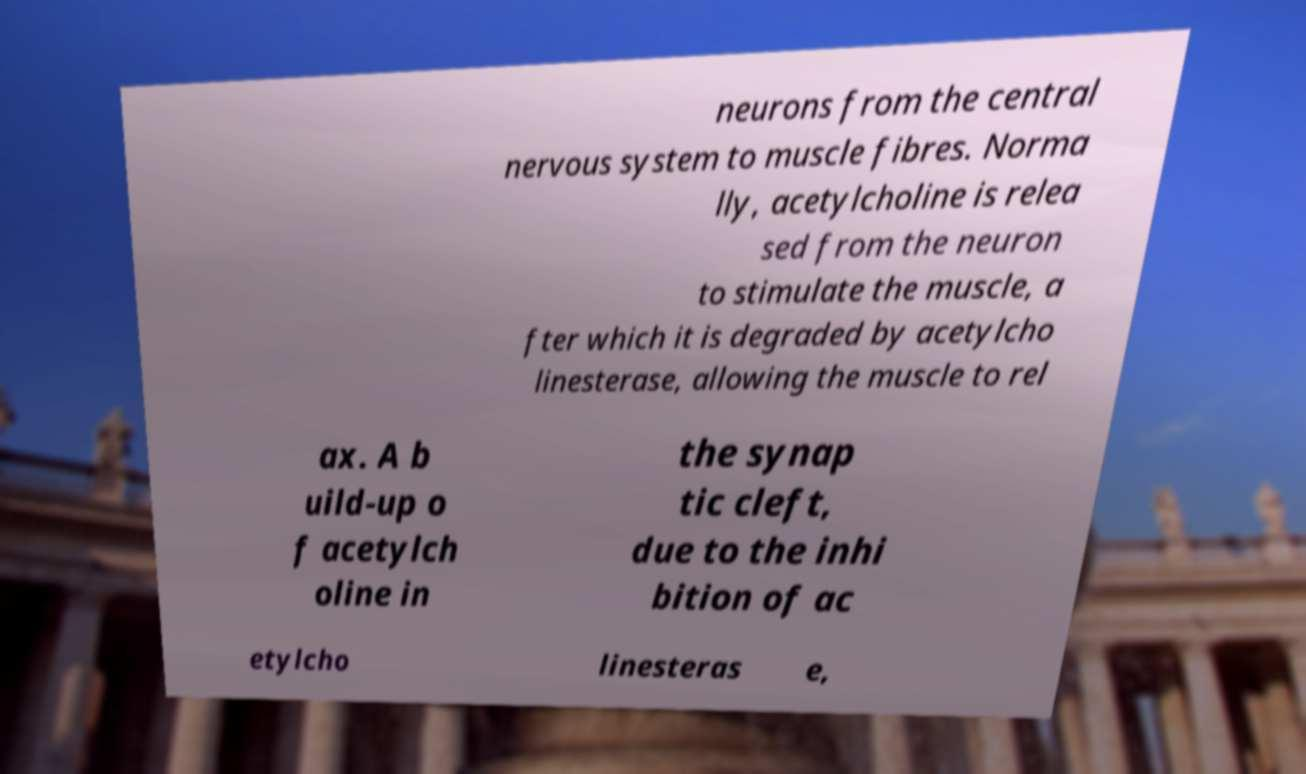Could you extract and type out the text from this image? neurons from the central nervous system to muscle fibres. Norma lly, acetylcholine is relea sed from the neuron to stimulate the muscle, a fter which it is degraded by acetylcho linesterase, allowing the muscle to rel ax. A b uild-up o f acetylch oline in the synap tic cleft, due to the inhi bition of ac etylcho linesteras e, 